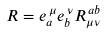Convert formula to latex. <formula><loc_0><loc_0><loc_500><loc_500>R = e ^ { \, \mu } _ { a } e ^ { \, \nu } _ { b } R ^ { \, a b } _ { \mu \nu }</formula> 